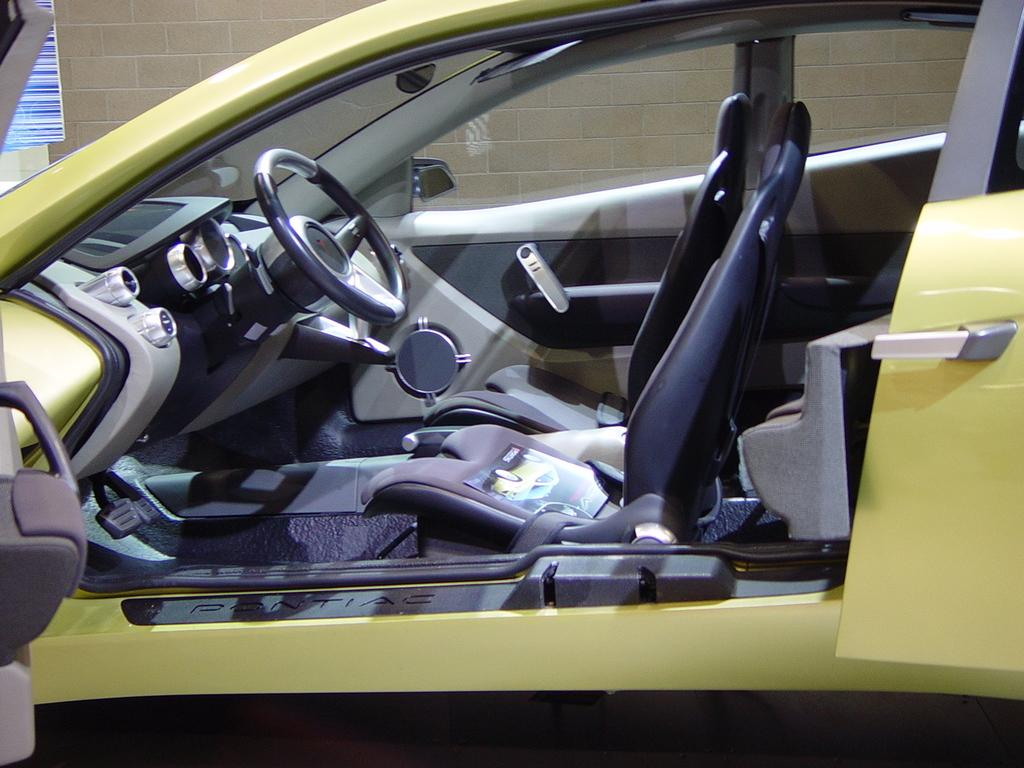What is the main subject of the image? The main subject of the image is a car. What parts of the car can be seen in the image? The car's seat, steering wheel, mirror, and window are visible in the image. What is visible through the car's window? A wall is visible through the car's window. What is the income of the person driving the car in the image? There is no information about the person driving the car or their income in the image. What angle is the car parked at in the image? The angle at which the car is parked is not visible or mentioned in the image. 